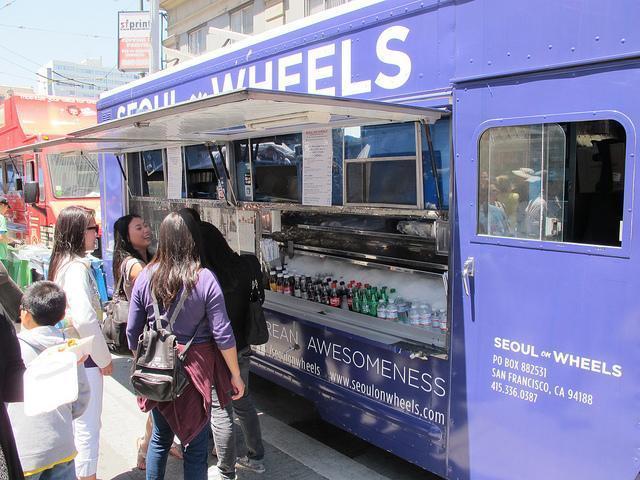How many billboards do you see?
Give a very brief answer. 1. How many backpacks can you see?
Give a very brief answer. 1. How many people are there?
Give a very brief answer. 6. How many trucks are there?
Give a very brief answer. 2. How many kites are flying?
Give a very brief answer. 0. 